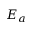<formula> <loc_0><loc_0><loc_500><loc_500>E _ { a }</formula> 